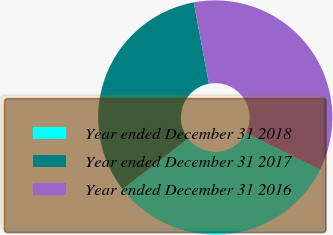<chart> <loc_0><loc_0><loc_500><loc_500><pie_chart><fcel>Year ended December 31 2018<fcel>Year ended December 31 2017<fcel>Year ended December 31 2016<nl><fcel>32.22%<fcel>32.52%<fcel>35.25%<nl></chart> 